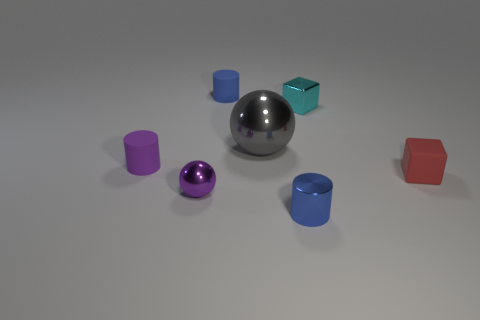Are there any small red blocks on the left side of the blue matte cylinder?
Offer a terse response. No. How many other objects are there of the same size as the purple cylinder?
Provide a short and direct response. 5. What is the material of the cylinder that is both behind the shiny cylinder and right of the tiny purple cylinder?
Give a very brief answer. Rubber. Does the blue object behind the tiny blue metal cylinder have the same shape as the small shiny thing that is behind the tiny purple shiny sphere?
Ensure brevity in your answer.  No. Is there anything else that has the same material as the purple sphere?
Your answer should be compact. Yes. There is a blue thing that is left of the metal ball behind the small block that is in front of the purple rubber thing; what is its shape?
Ensure brevity in your answer.  Cylinder. What number of other objects are there of the same shape as the large shiny object?
Make the answer very short. 1. What color is the other block that is the same size as the red cube?
Give a very brief answer. Cyan. What number of cubes are either small cyan shiny things or small red rubber objects?
Your response must be concise. 2. How many matte things are there?
Offer a terse response. 3. 